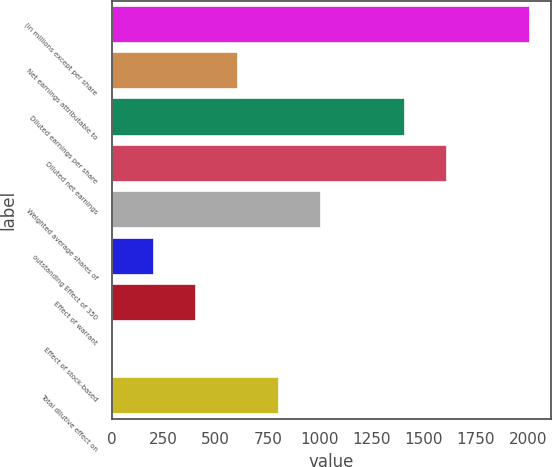Convert chart to OTSL. <chart><loc_0><loc_0><loc_500><loc_500><bar_chart><fcel>(in millions except per share<fcel>Net earnings attributable to<fcel>Diluted earnings per share<fcel>Diluted net earnings<fcel>Weighted average shares of<fcel>outstanding Effect of 350<fcel>Effect of warrant<fcel>Effect of stock-based<fcel>Total dilutive effect on<nl><fcel>2012<fcel>605<fcel>1409<fcel>1610<fcel>1007<fcel>203<fcel>404<fcel>2<fcel>806<nl></chart> 